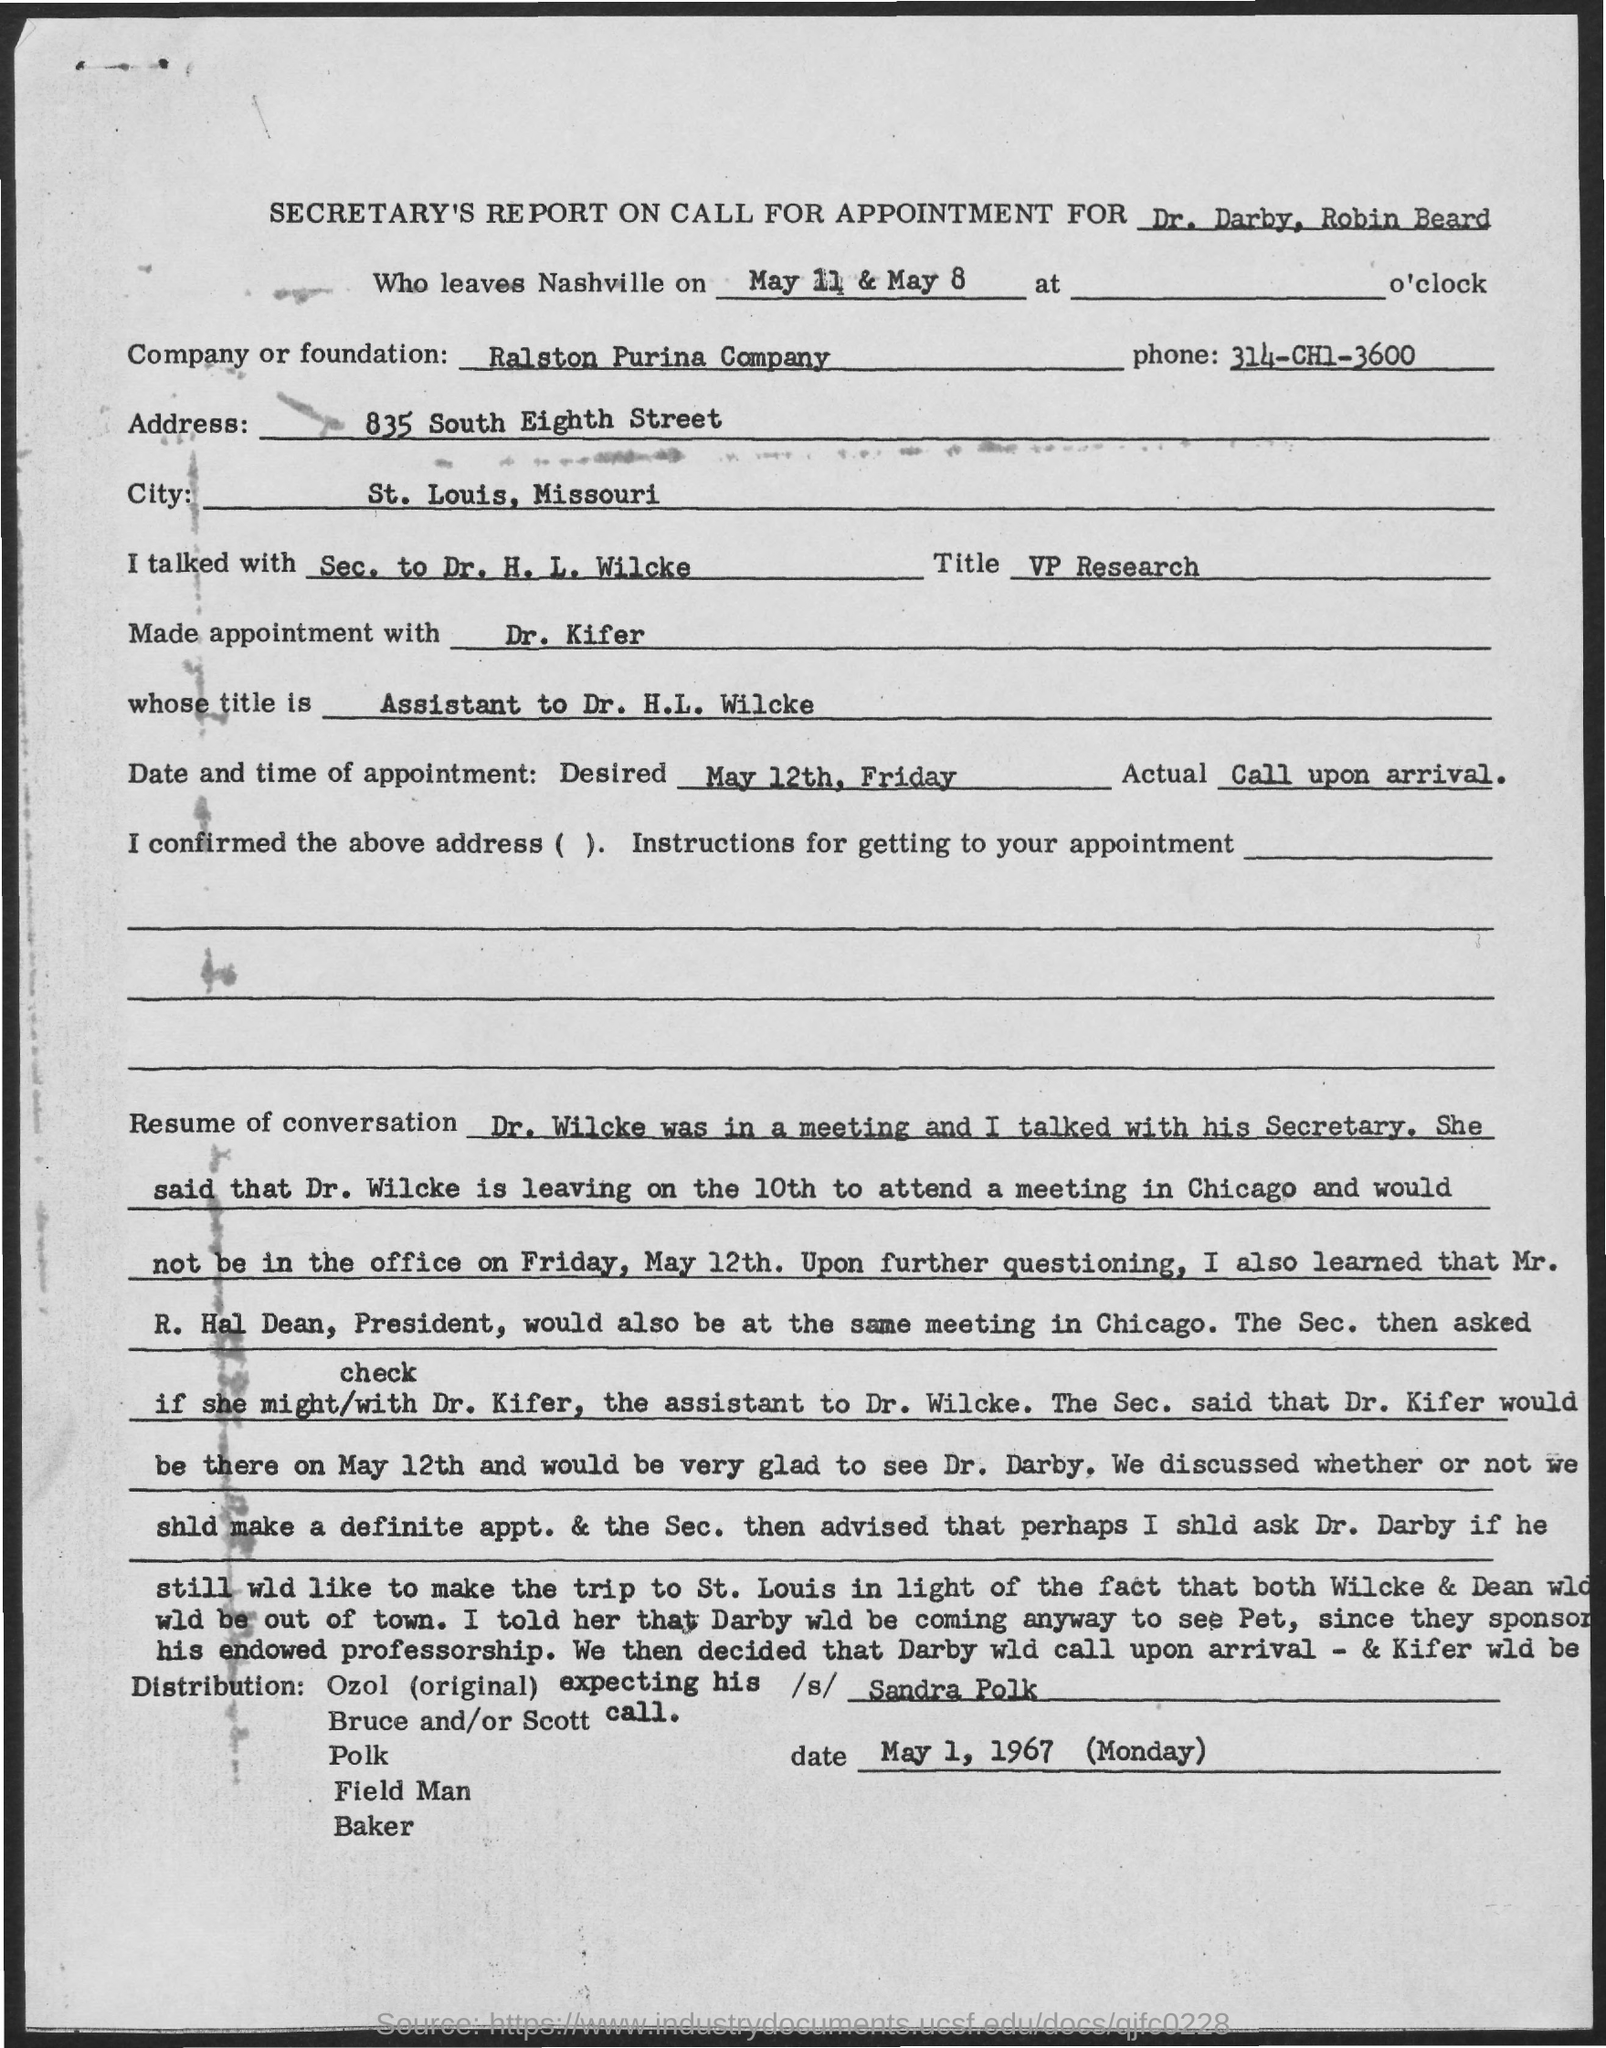Indicate a few pertinent items in this graphic. The phone number is 314-CH1-3600. The desired date of the appointment is May 12th, which is a Friday. The Ralston Purina Company is the name of the company or foundation. The address of Ralston Purina Company is located at 835 South Eighth Street. The title of Dr. H.L. Wilcke is Vice President of Research. 